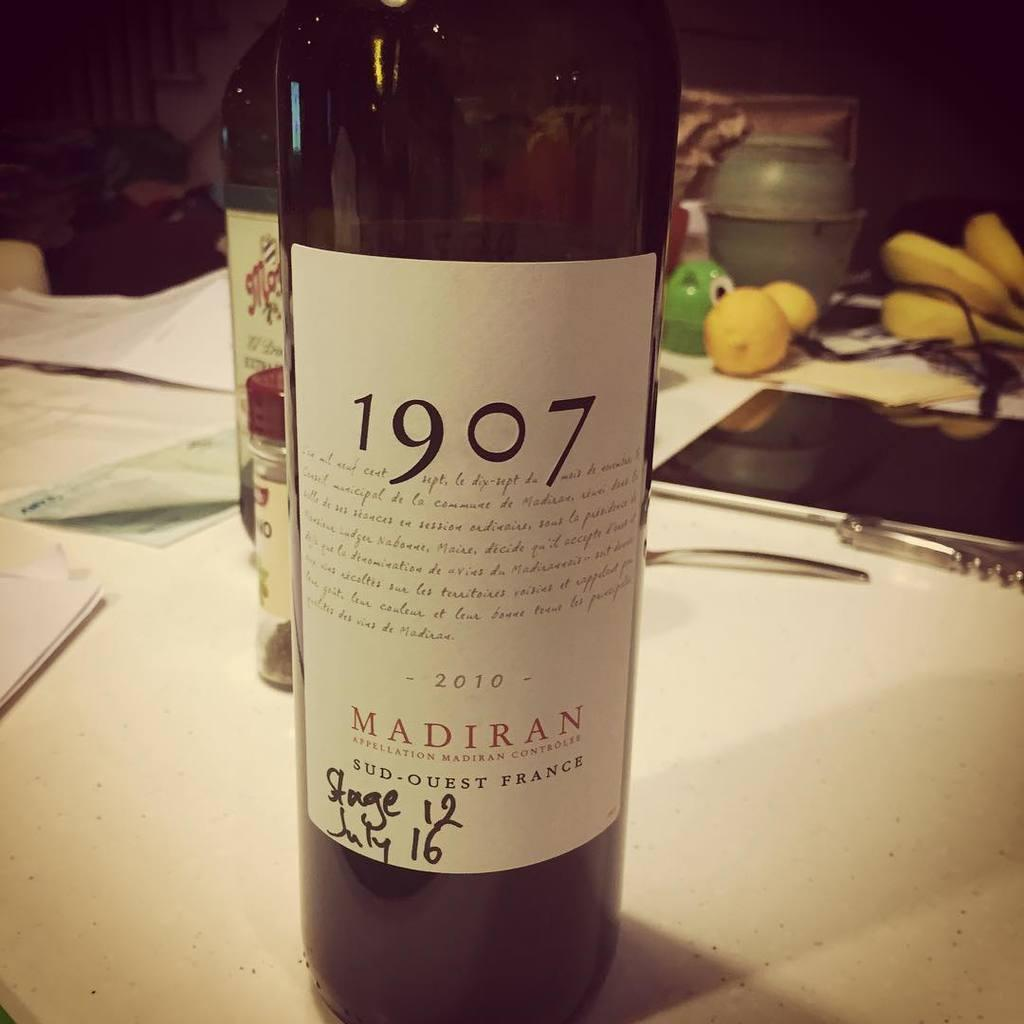<image>
Write a terse but informative summary of the picture. A bottle of wine from 1907 called Madiran on a table with various items including fruit in the background. 